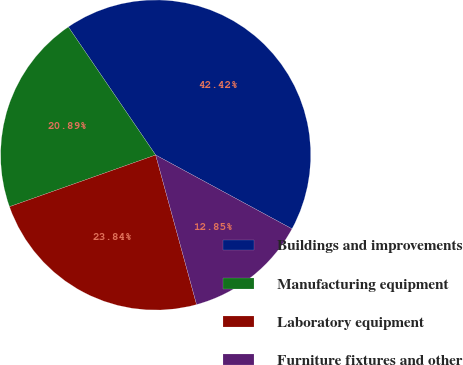Convert chart. <chart><loc_0><loc_0><loc_500><loc_500><pie_chart><fcel>Buildings and improvements<fcel>Manufacturing equipment<fcel>Laboratory equipment<fcel>Furniture fixtures and other<nl><fcel>42.42%<fcel>20.89%<fcel>23.84%<fcel>12.85%<nl></chart> 